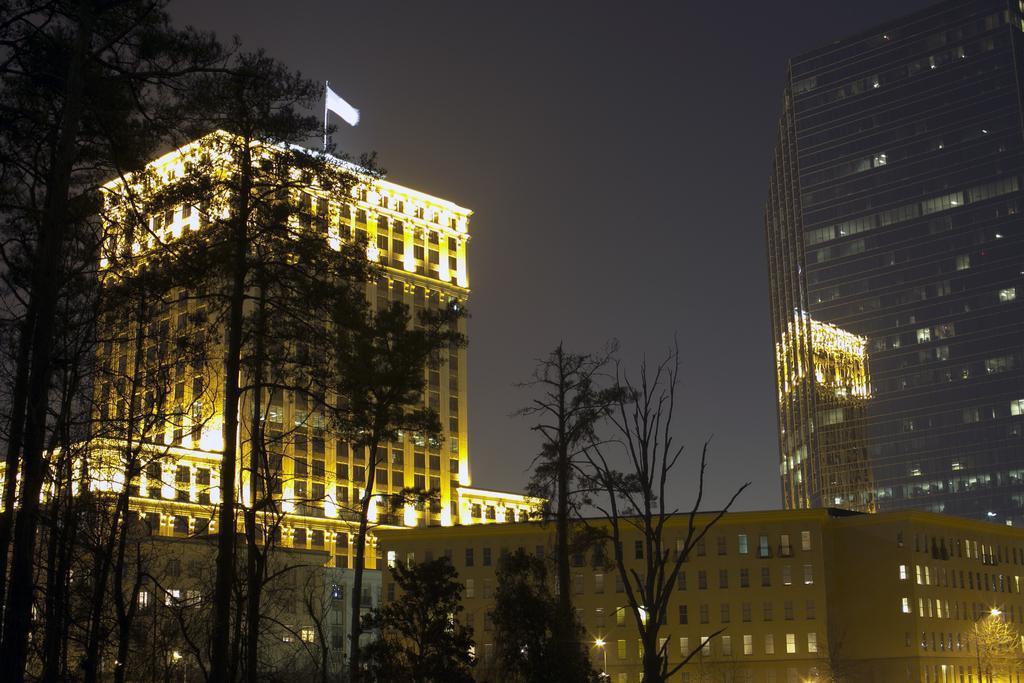How would you summarize this image in a sentence or two? In this image there are trees, buildings and a sky. 